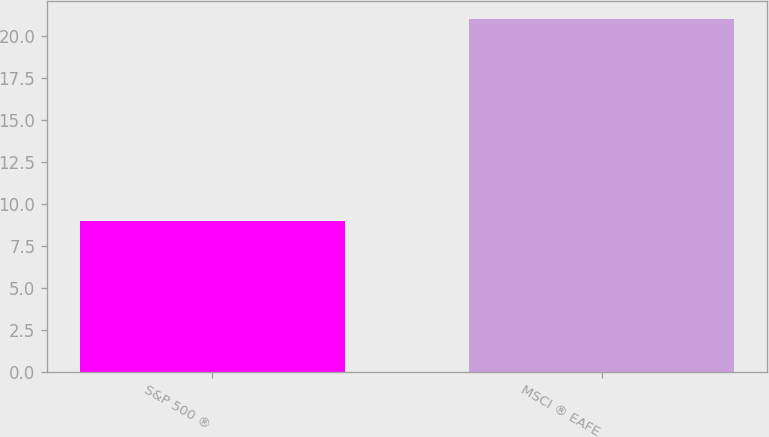Convert chart. <chart><loc_0><loc_0><loc_500><loc_500><bar_chart><fcel>S&P 500 ®<fcel>MSCI ® EAFE<nl><fcel>9<fcel>21<nl></chart> 